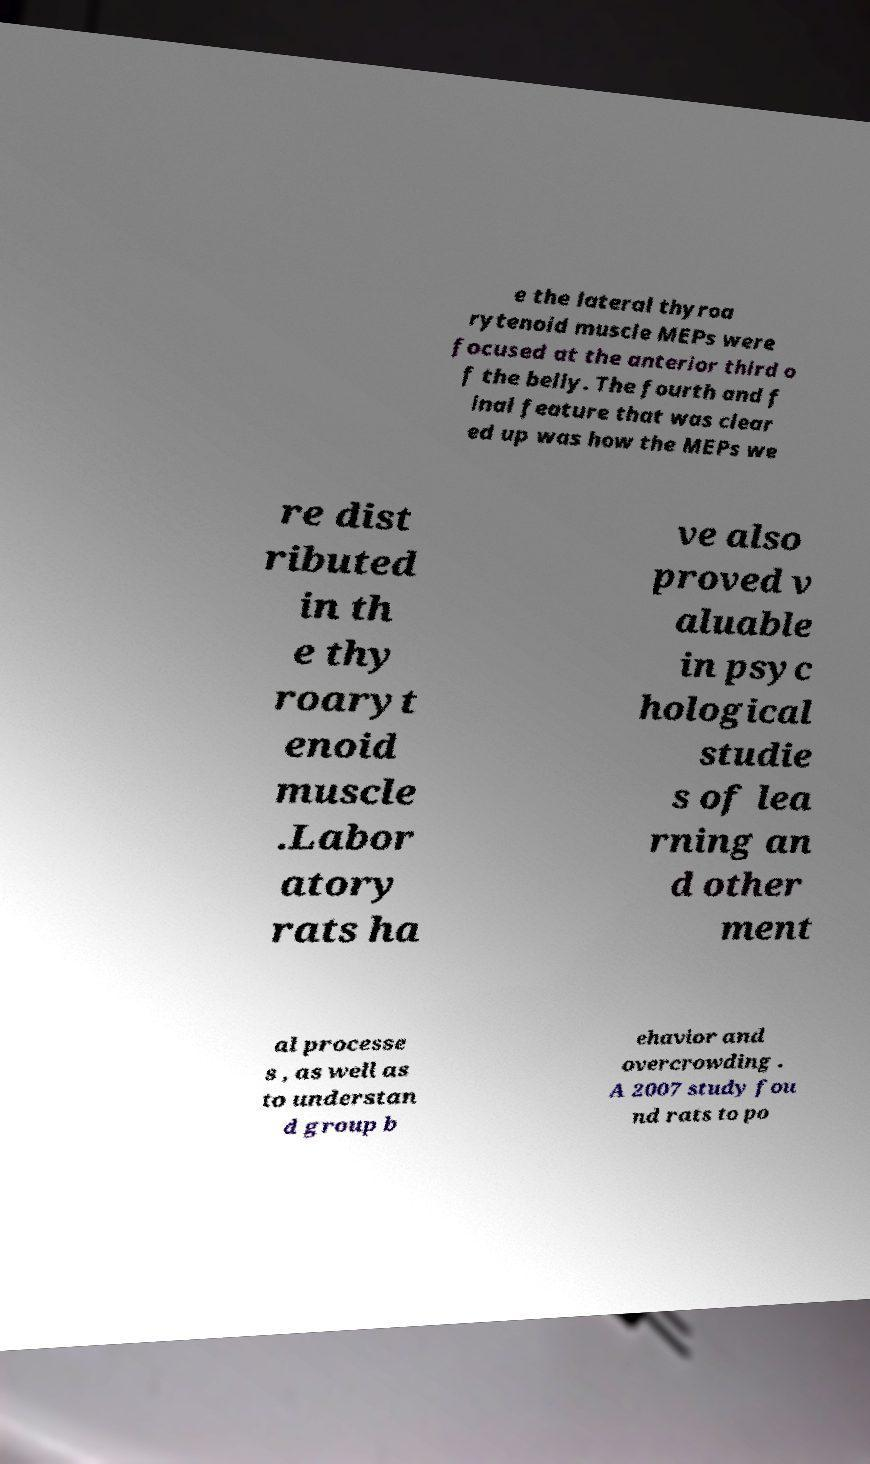Can you read and provide the text displayed in the image?This photo seems to have some interesting text. Can you extract and type it out for me? e the lateral thyroa rytenoid muscle MEPs were focused at the anterior third o f the belly. The fourth and f inal feature that was clear ed up was how the MEPs we re dist ributed in th e thy roaryt enoid muscle .Labor atory rats ha ve also proved v aluable in psyc hological studie s of lea rning an d other ment al processe s , as well as to understan d group b ehavior and overcrowding . A 2007 study fou nd rats to po 